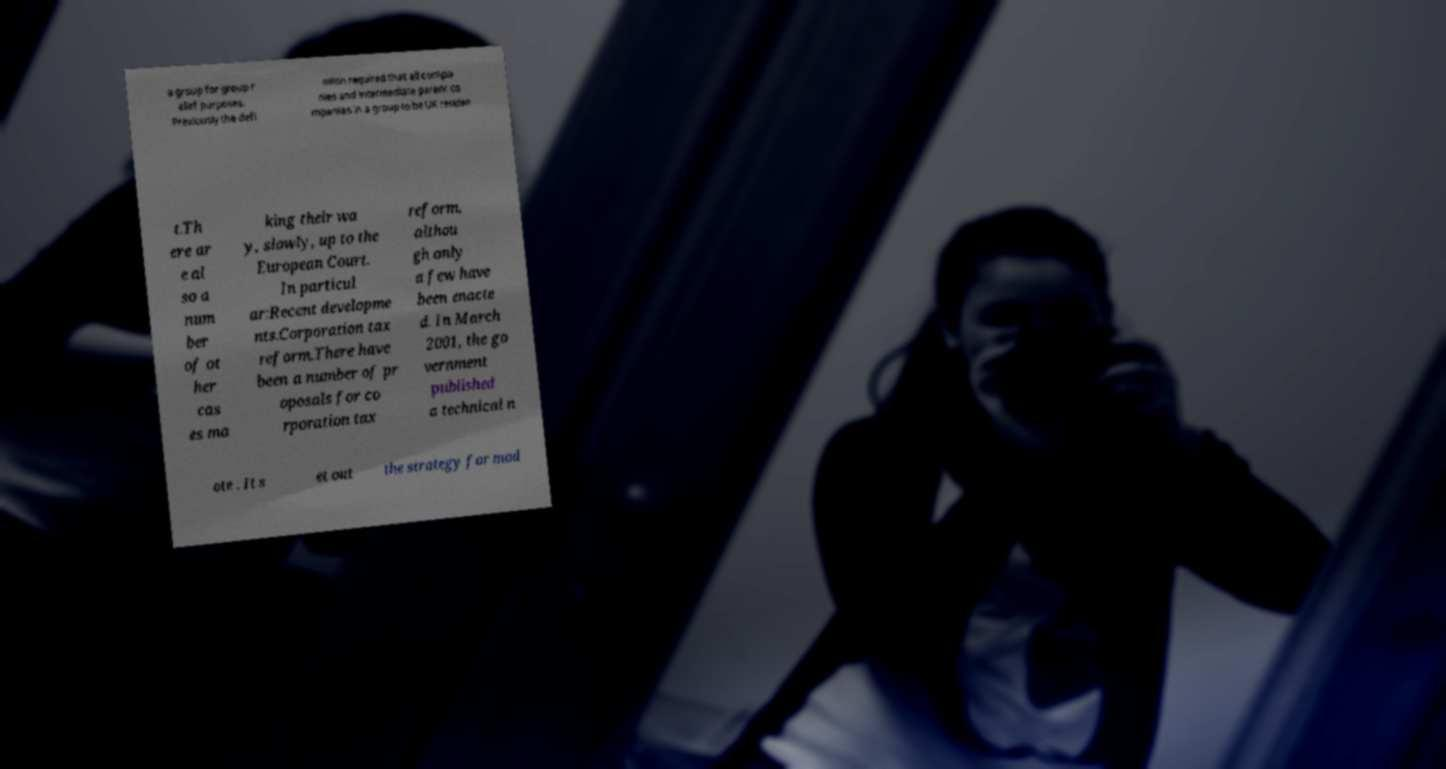Can you read and provide the text displayed in the image?This photo seems to have some interesting text. Can you extract and type it out for me? a group for group r elief purposes. Previously the defi nition required that all compa nies and intermediate parent co mpanies in a group to be UK residen t.Th ere ar e al so a num ber of ot her cas es ma king their wa y, slowly, up to the European Court. In particul ar:Recent developme nts.Corporation tax reform.There have been a number of pr oposals for co rporation tax reform, althou gh only a few have been enacte d. In March 2001, the go vernment published a technical n ote . It s et out the strategy for mod 